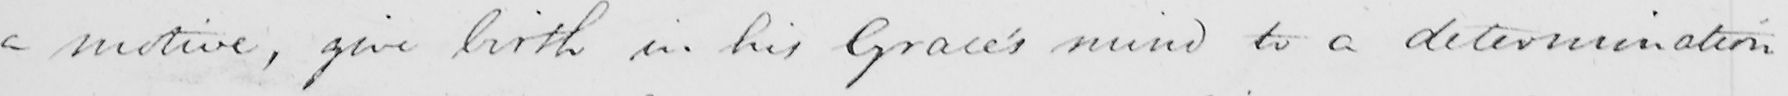What text is written in this handwritten line? a motive , give birth in his Grace ' s mind to a determination 